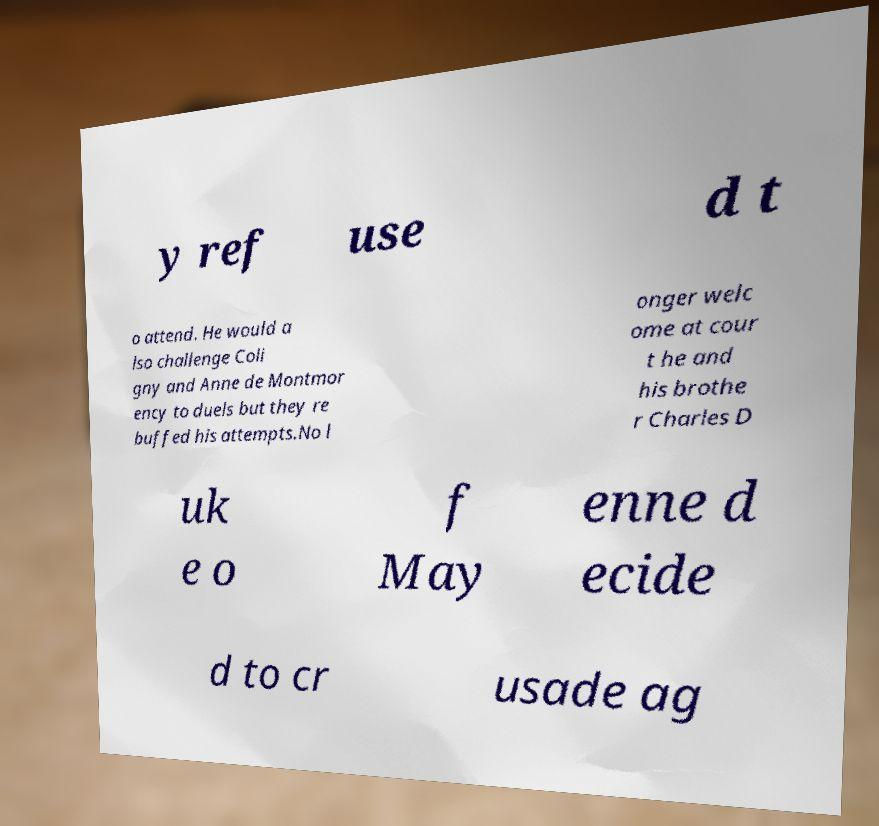Could you assist in decoding the text presented in this image and type it out clearly? y ref use d t o attend. He would a lso challenge Coli gny and Anne de Montmor ency to duels but they re buffed his attempts.No l onger welc ome at cour t he and his brothe r Charles D uk e o f May enne d ecide d to cr usade ag 